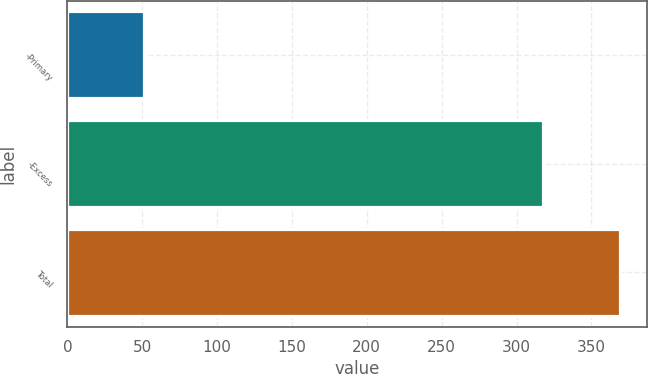Convert chart to OTSL. <chart><loc_0><loc_0><loc_500><loc_500><bar_chart><fcel>-Primary<fcel>-Excess<fcel>Total<nl><fcel>51<fcel>318<fcel>369<nl></chart> 